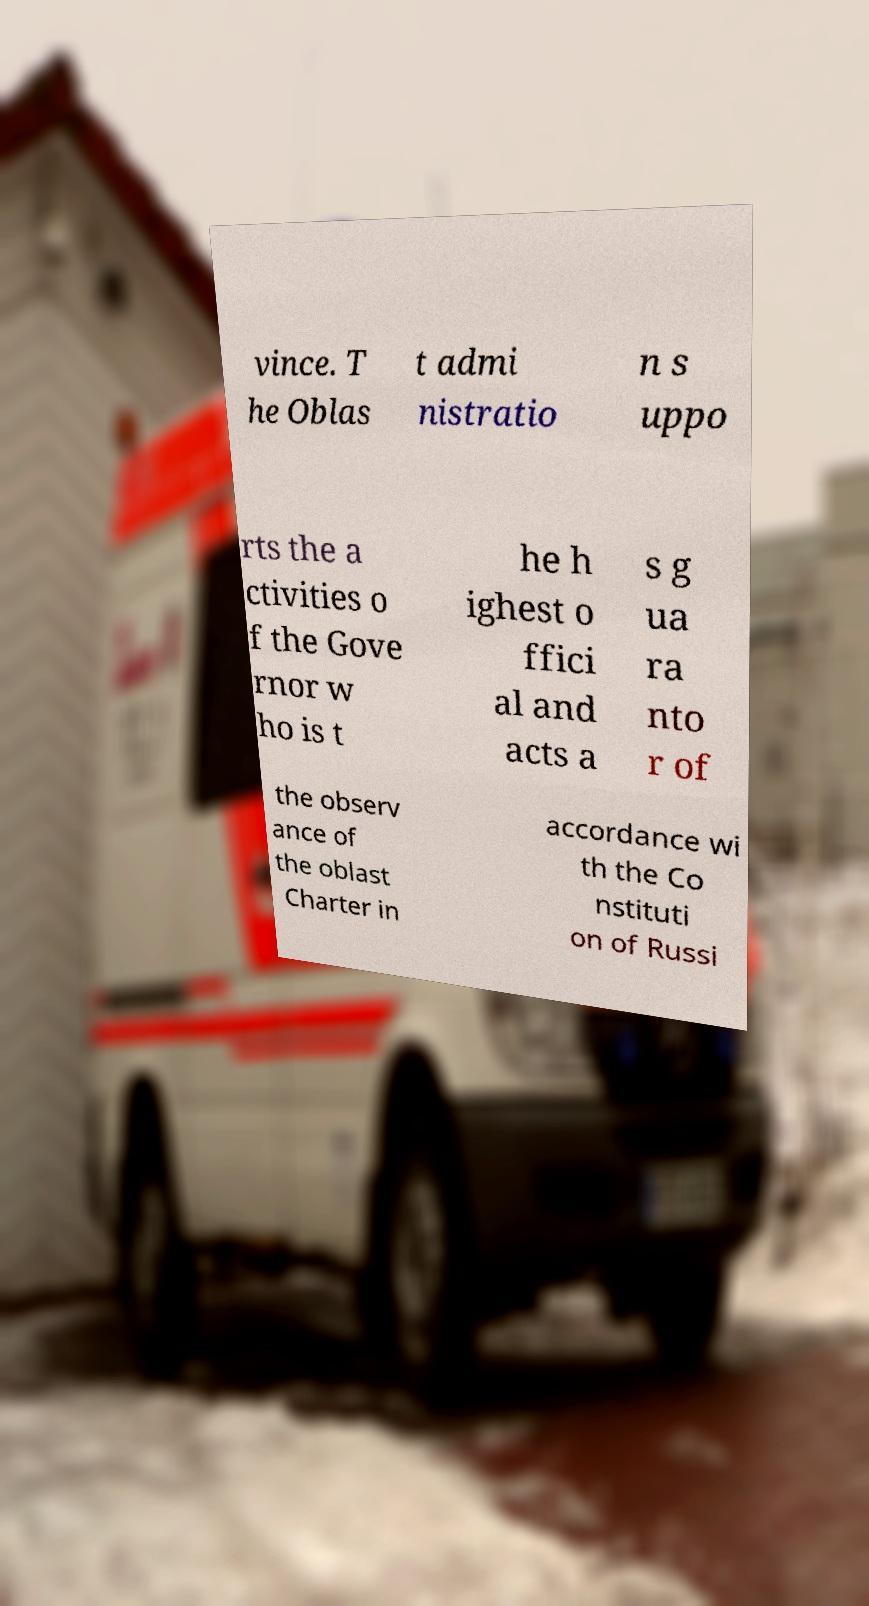Could you assist in decoding the text presented in this image and type it out clearly? vince. T he Oblas t admi nistratio n s uppo rts the a ctivities o f the Gove rnor w ho is t he h ighest o ffici al and acts a s g ua ra nto r of the observ ance of the oblast Charter in accordance wi th the Co nstituti on of Russi 